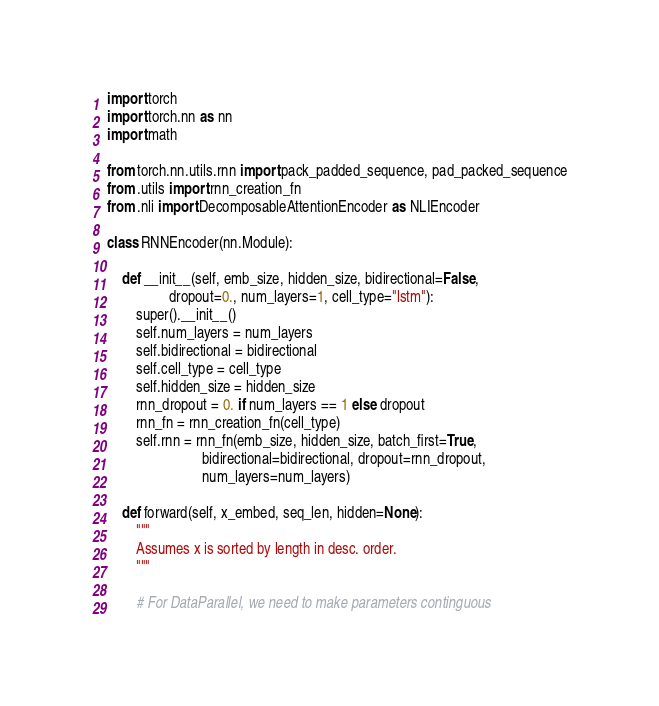<code> <loc_0><loc_0><loc_500><loc_500><_Python_>import torch
import torch.nn as nn
import math

from torch.nn.utils.rnn import pack_padded_sequence, pad_packed_sequence
from .utils import rnn_creation_fn
from .nli import DecomposableAttentionEncoder as NLIEncoder

class RNNEncoder(nn.Module):

    def __init__(self, emb_size, hidden_size, bidirectional=False,
                 dropout=0., num_layers=1, cell_type="lstm"):
        super().__init__()
        self.num_layers = num_layers
        self.bidirectional = bidirectional
        self.cell_type = cell_type
        self.hidden_size = hidden_size
        rnn_dropout = 0. if num_layers == 1 else dropout
        rnn_fn = rnn_creation_fn(cell_type)
        self.rnn = rnn_fn(emb_size, hidden_size, batch_first=True,
                          bidirectional=bidirectional, dropout=rnn_dropout,
                          num_layers=num_layers)

    def forward(self, x_embed, seq_len, hidden=None):
        """
        Assumes x is sorted by length in desc. order.
        """

        # For DataParallel, we need to make parameters continguous</code> 